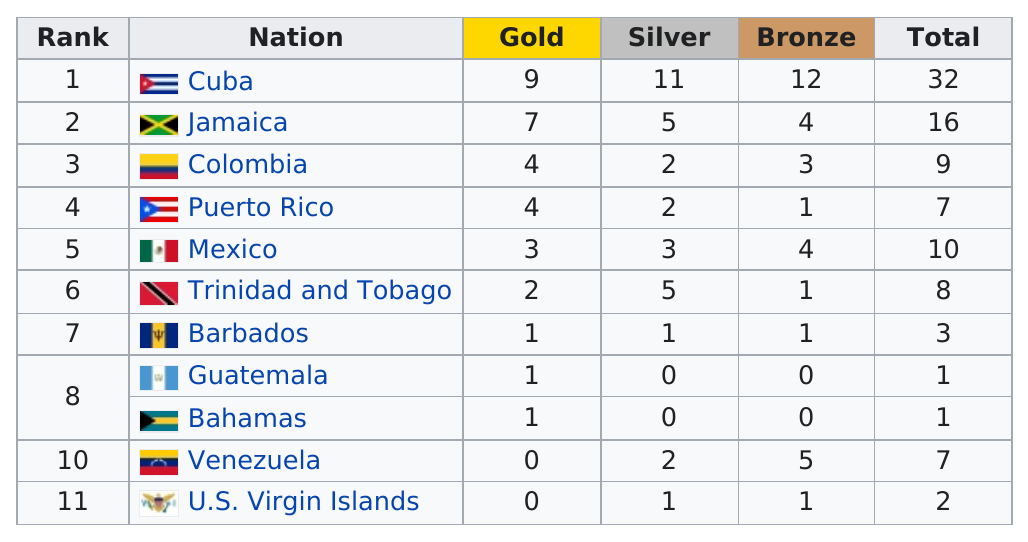Highlight a few significant elements in this photo. There are currently three teams that have earned more than nine medals. Cuba, Jamaica, and Mexico are nations that won 10 or more medals each. Cuba has won the most medals. The total number of gold medals awarded between these 11 countries is 32. Puerto Rico is the nation that precedes Mexico in the table. 